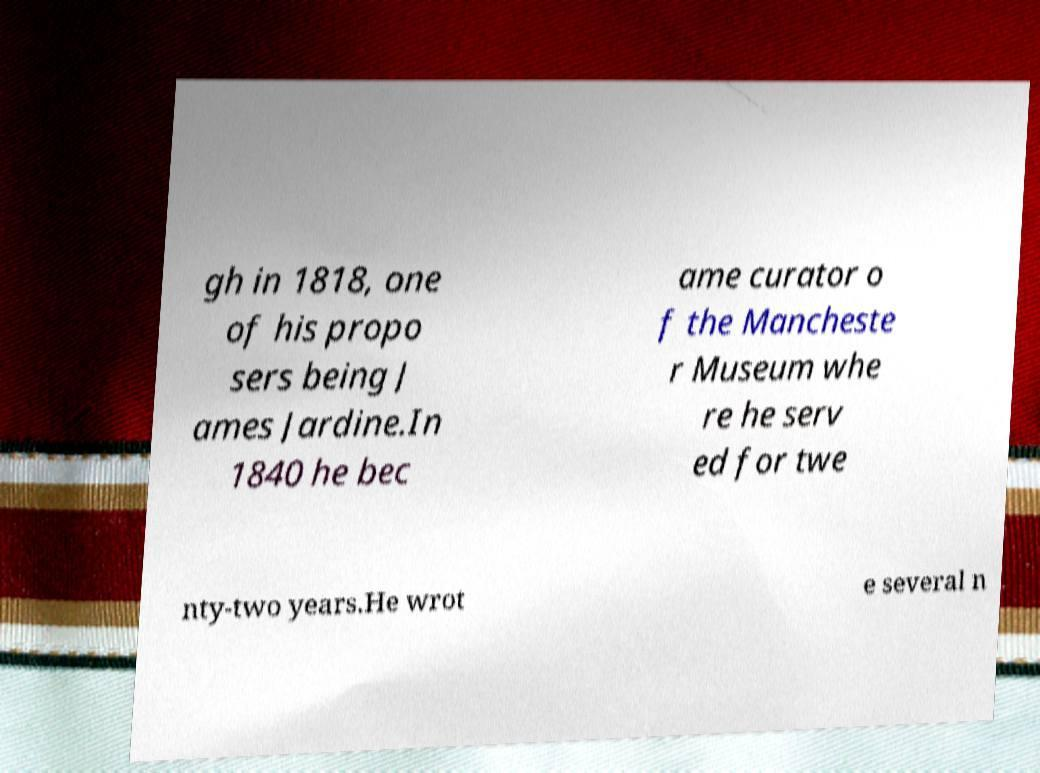Can you read and provide the text displayed in the image?This photo seems to have some interesting text. Can you extract and type it out for me? gh in 1818, one of his propo sers being J ames Jardine.In 1840 he bec ame curator o f the Mancheste r Museum whe re he serv ed for twe nty-two years.He wrot e several n 